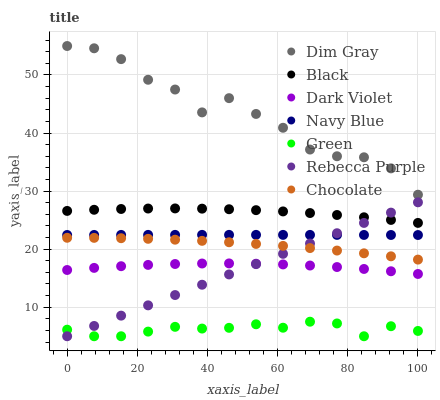Does Green have the minimum area under the curve?
Answer yes or no. Yes. Does Dim Gray have the maximum area under the curve?
Answer yes or no. Yes. Does Navy Blue have the minimum area under the curve?
Answer yes or no. No. Does Navy Blue have the maximum area under the curve?
Answer yes or no. No. Is Rebecca Purple the smoothest?
Answer yes or no. Yes. Is Dim Gray the roughest?
Answer yes or no. Yes. Is Navy Blue the smoothest?
Answer yes or no. No. Is Navy Blue the roughest?
Answer yes or no. No. Does Rebecca Purple have the lowest value?
Answer yes or no. Yes. Does Navy Blue have the lowest value?
Answer yes or no. No. Does Dim Gray have the highest value?
Answer yes or no. Yes. Does Navy Blue have the highest value?
Answer yes or no. No. Is Green less than Black?
Answer yes or no. Yes. Is Navy Blue greater than Chocolate?
Answer yes or no. Yes. Does Rebecca Purple intersect Green?
Answer yes or no. Yes. Is Rebecca Purple less than Green?
Answer yes or no. No. Is Rebecca Purple greater than Green?
Answer yes or no. No. Does Green intersect Black?
Answer yes or no. No. 